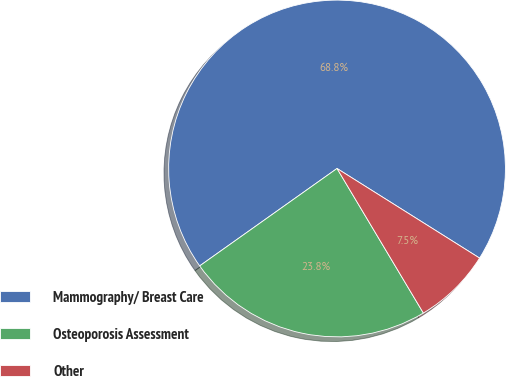<chart> <loc_0><loc_0><loc_500><loc_500><pie_chart><fcel>Mammography/ Breast Care<fcel>Osteoporosis Assessment<fcel>Other<nl><fcel>68.75%<fcel>23.75%<fcel>7.5%<nl></chart> 